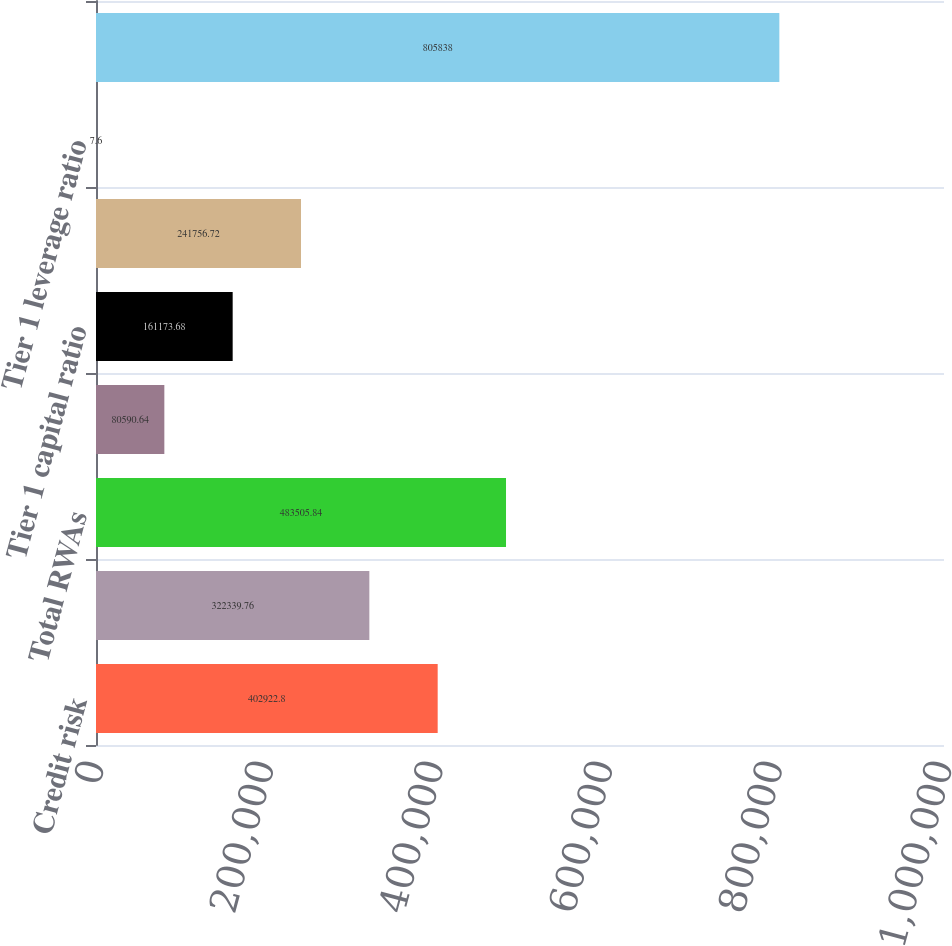<chart> <loc_0><loc_0><loc_500><loc_500><bar_chart><fcel>Credit risk<fcel>Market risk<fcel>Total RWAs<fcel>Common Equity Tier 1<fcel>Tier 1 capital ratio<fcel>Total capital ratio<fcel>Tier 1 leverage ratio<fcel>Adjusted average assets<nl><fcel>402923<fcel>322340<fcel>483506<fcel>80590.6<fcel>161174<fcel>241757<fcel>7.6<fcel>805838<nl></chart> 